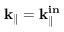<formula> <loc_0><loc_0><loc_500><loc_500>k _ { \| } = k _ { \| } ^ { i n }</formula> 